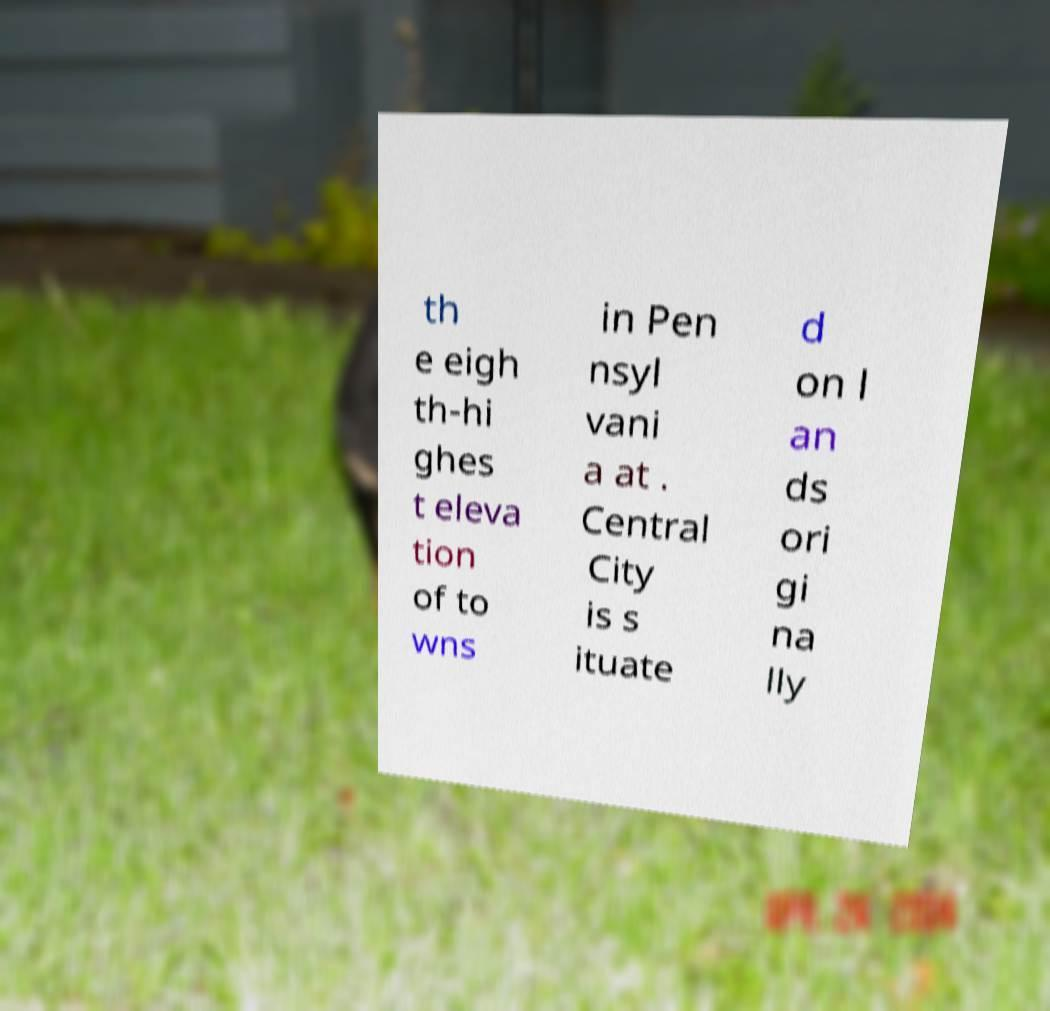For documentation purposes, I need the text within this image transcribed. Could you provide that? th e eigh th-hi ghes t eleva tion of to wns in Pen nsyl vani a at . Central City is s ituate d on l an ds ori gi na lly 